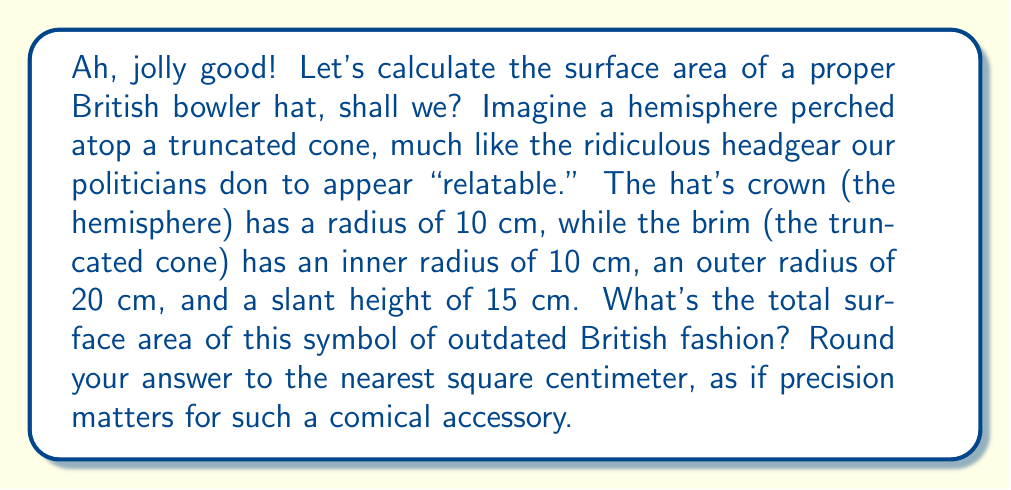Can you answer this question? Right then, let's dissect this fashion faux pas step-by-step:

1) For the crown (hemisphere):
   Surface area = $2\pi r^2$
   $$A_{crown} = 2\pi (10\text{ cm})^2 = 200\pi \text{ cm}^2$$

2) For the brim (truncated cone):
   We need the lateral surface area and the area of the ring-shaped bottom.
   
   Lateral surface area = $\pi(r_1 + r_2)s$, where $s$ is the slant height
   $$A_{lateral} = \pi(10\text{ cm} + 20\text{ cm})(15\text{ cm}) = 450\pi \text{ cm}^2$$
   
   Area of the ring = $\pi(r_2^2 - r_1^2)$
   $$A_{ring} = \pi((20\text{ cm})^2 - (10\text{ cm})^2) = 300\pi \text{ cm}^2$$

3) Total surface area of the brim:
   $$A_{brim} = A_{lateral} + A_{ring} = 450\pi \text{ cm}^2 + 300\pi \text{ cm}^2 = 750\pi \text{ cm}^2$$

4) Total surface area of the bowler hat:
   $$A_{total} = A_{crown} + A_{brim} = 200\pi \text{ cm}^2 + 750\pi \text{ cm}^2 = 950\pi \text{ cm}^2$$

5) Converting to a numerical value and rounding:
   $$A_{total} = 950\pi \text{ cm}^2 \approx 2,984.51 \text{ cm}^2 \approx 2,985 \text{ cm}^2$$

There you have it, a perfectly calculated surface area for a perfectly impractical hat.
Answer: 2,985 cm² 